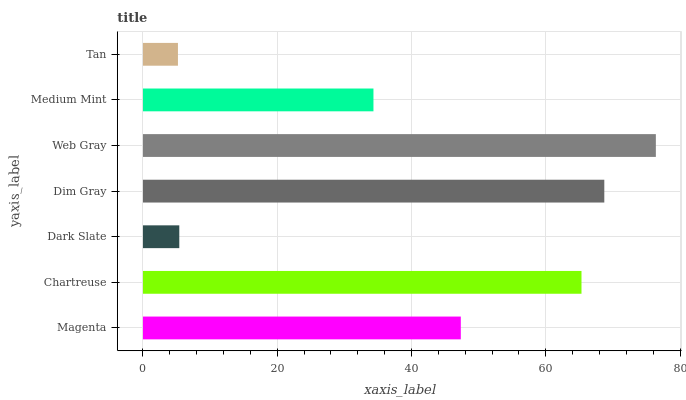Is Tan the minimum?
Answer yes or no. Yes. Is Web Gray the maximum?
Answer yes or no. Yes. Is Chartreuse the minimum?
Answer yes or no. No. Is Chartreuse the maximum?
Answer yes or no. No. Is Chartreuse greater than Magenta?
Answer yes or no. Yes. Is Magenta less than Chartreuse?
Answer yes or no. Yes. Is Magenta greater than Chartreuse?
Answer yes or no. No. Is Chartreuse less than Magenta?
Answer yes or no. No. Is Magenta the high median?
Answer yes or no. Yes. Is Magenta the low median?
Answer yes or no. Yes. Is Tan the high median?
Answer yes or no. No. Is Chartreuse the low median?
Answer yes or no. No. 